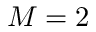Convert formula to latex. <formula><loc_0><loc_0><loc_500><loc_500>M = 2</formula> 